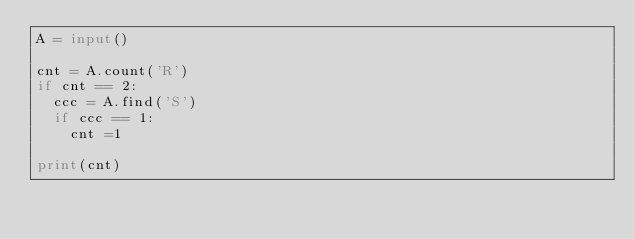<code> <loc_0><loc_0><loc_500><loc_500><_Python_>A = input()

cnt = A.count('R')
if cnt == 2:
  ccc = A.find('S')
  if ccc == 1:
    cnt =1

print(cnt)</code> 